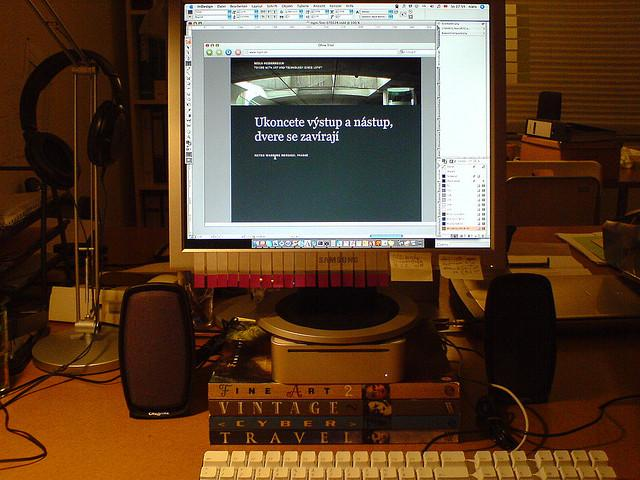What is the monitor sitting on top of above the desk? books 